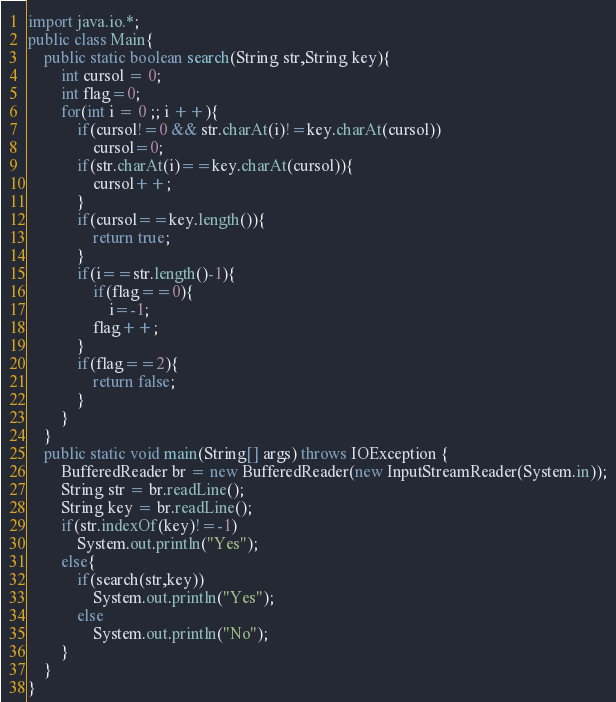Convert code to text. <code><loc_0><loc_0><loc_500><loc_500><_Java_>import java.io.*;
public class Main{
	public static boolean search(String str,String key){
		int cursol = 0;
		int flag=0;
		for(int i = 0 ;; i ++){
			if(cursol!=0 && str.charAt(i)!=key.charAt(cursol))
				cursol=0;
			if(str.charAt(i)==key.charAt(cursol)){
				cursol++;
			}
			if(cursol==key.length()){
				return true;
			}
			if(i==str.length()-1){
				if(flag==0){
					i=-1;
				flag++;
			}
			if(flag==2){
				return false;
			}
		}
	}
	public static void main(String[] args) throws IOException {
		BufferedReader br = new BufferedReader(new InputStreamReader(System.in));
		String str = br.readLine();
		String key = br.readLine();
		if(str.indexOf(key)!=-1)
			System.out.println("Yes");
		else{
			if(search(str,key))
				System.out.println("Yes");
			else
				System.out.println("No");
		}
	}
}</code> 